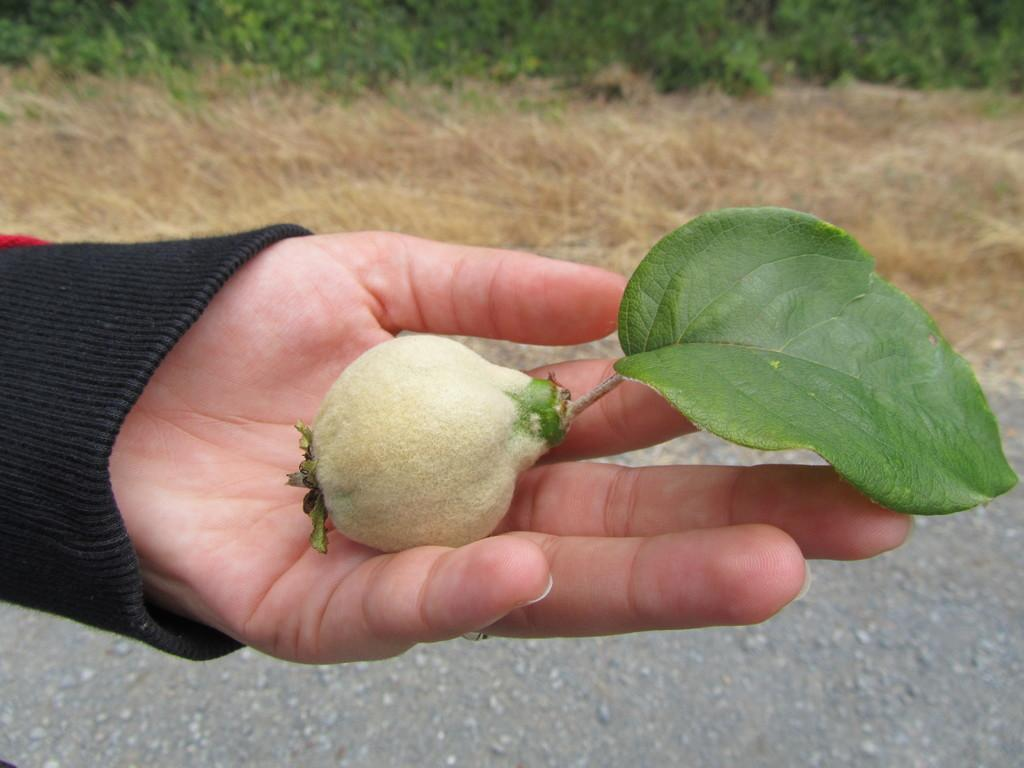What is being held in the human hand in the image? There is a fruit in a human hand in the image. What type of plant is represented by the leaf in the image? There is a green color leaf in the image. What type of man-made structure can be seen in the image? There is a road visible in the image. What type of natural environment is visible in the background of the image? There is dried grass and plants on the ground in the background of the image. What type of government is being discussed in the image? There is no discussion of government in the image; it features a fruit in a human hand, a green leaf, a road, dried grass, and plants in the background. Is there a tent visible in the image? No, there is no tent present in the image. 